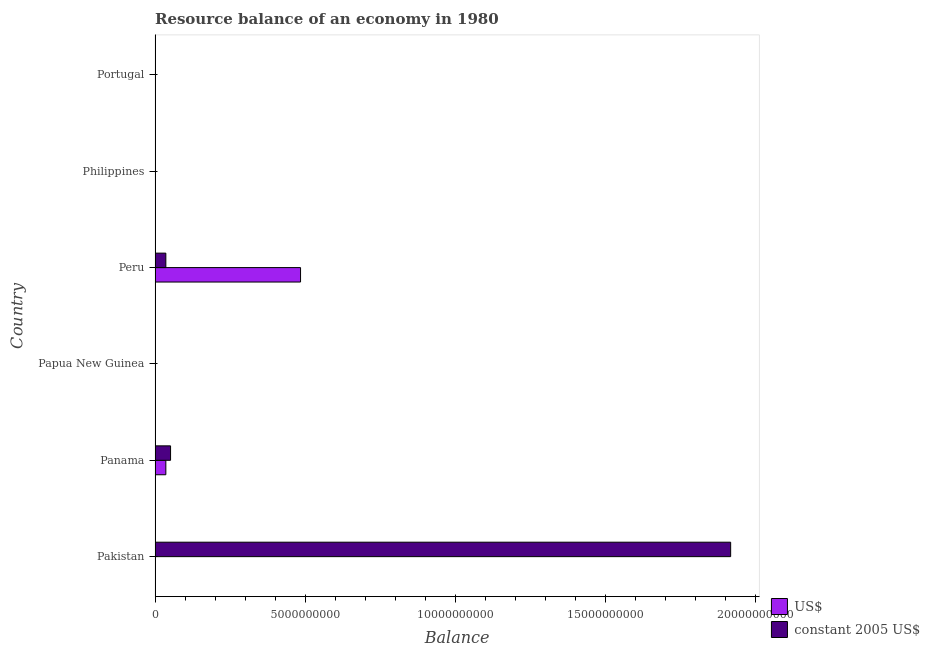How many different coloured bars are there?
Offer a terse response. 2. How many bars are there on the 5th tick from the top?
Your answer should be compact. 2. How many bars are there on the 3rd tick from the bottom?
Offer a terse response. 0. In how many cases, is the number of bars for a given country not equal to the number of legend labels?
Keep it short and to the point. 4. Across all countries, what is the maximum resource balance in constant us$?
Offer a very short reply. 1.92e+1. Across all countries, what is the minimum resource balance in constant us$?
Keep it short and to the point. 0. What is the total resource balance in us$ in the graph?
Give a very brief answer. 5.21e+09. What is the difference between the resource balance in constant us$ in Peru and that in Portugal?
Ensure brevity in your answer.  3.59e+08. What is the average resource balance in constant us$ per country?
Make the answer very short. 3.34e+09. What is the difference between the resource balance in constant us$ and resource balance in us$ in Peru?
Provide a short and direct response. -4.49e+09. What is the ratio of the resource balance in constant us$ in Panama to that in Peru?
Provide a succinct answer. 1.44. What is the difference between the highest and the second highest resource balance in constant us$?
Your answer should be very brief. 1.87e+1. What is the difference between the highest and the lowest resource balance in us$?
Offer a very short reply. 4.85e+09. In how many countries, is the resource balance in constant us$ greater than the average resource balance in constant us$ taken over all countries?
Ensure brevity in your answer.  1. Are the values on the major ticks of X-axis written in scientific E-notation?
Provide a short and direct response. No. Does the graph contain grids?
Your response must be concise. No. Where does the legend appear in the graph?
Your response must be concise. Bottom right. How many legend labels are there?
Provide a short and direct response. 2. What is the title of the graph?
Provide a succinct answer. Resource balance of an economy in 1980. Does "Young" appear as one of the legend labels in the graph?
Your response must be concise. No. What is the label or title of the X-axis?
Provide a short and direct response. Balance. What is the Balance of US$ in Pakistan?
Your answer should be very brief. 0. What is the Balance in constant 2005 US$ in Pakistan?
Ensure brevity in your answer.  1.92e+1. What is the Balance of US$ in Panama?
Ensure brevity in your answer.  3.59e+08. What is the Balance in constant 2005 US$ in Panama?
Your answer should be very brief. 5.17e+08. What is the Balance of US$ in Peru?
Your answer should be compact. 4.85e+09. What is the Balance in constant 2005 US$ in Peru?
Your answer should be very brief. 3.59e+08. What is the Balance in constant 2005 US$ in Philippines?
Ensure brevity in your answer.  0. What is the Balance in constant 2005 US$ in Portugal?
Ensure brevity in your answer.  1400. Across all countries, what is the maximum Balance of US$?
Give a very brief answer. 4.85e+09. Across all countries, what is the maximum Balance of constant 2005 US$?
Offer a very short reply. 1.92e+1. Across all countries, what is the minimum Balance in constant 2005 US$?
Keep it short and to the point. 0. What is the total Balance in US$ in the graph?
Give a very brief answer. 5.21e+09. What is the total Balance in constant 2005 US$ in the graph?
Offer a very short reply. 2.01e+1. What is the difference between the Balance of constant 2005 US$ in Pakistan and that in Panama?
Your response must be concise. 1.87e+1. What is the difference between the Balance in constant 2005 US$ in Pakistan and that in Peru?
Offer a terse response. 1.88e+1. What is the difference between the Balance in constant 2005 US$ in Pakistan and that in Portugal?
Your response must be concise. 1.92e+1. What is the difference between the Balance of US$ in Panama and that in Peru?
Provide a succinct answer. -4.49e+09. What is the difference between the Balance of constant 2005 US$ in Panama and that in Peru?
Give a very brief answer. 1.57e+08. What is the difference between the Balance of constant 2005 US$ in Panama and that in Portugal?
Your response must be concise. 5.17e+08. What is the difference between the Balance in constant 2005 US$ in Peru and that in Portugal?
Your answer should be very brief. 3.59e+08. What is the difference between the Balance in US$ in Panama and the Balance in constant 2005 US$ in Portugal?
Provide a succinct answer. 3.59e+08. What is the difference between the Balance in US$ in Peru and the Balance in constant 2005 US$ in Portugal?
Offer a very short reply. 4.85e+09. What is the average Balance in US$ per country?
Offer a terse response. 8.68e+08. What is the average Balance in constant 2005 US$ per country?
Provide a succinct answer. 3.34e+09. What is the difference between the Balance of US$ and Balance of constant 2005 US$ in Panama?
Your answer should be very brief. -1.57e+08. What is the difference between the Balance in US$ and Balance in constant 2005 US$ in Peru?
Offer a very short reply. 4.49e+09. What is the ratio of the Balance of constant 2005 US$ in Pakistan to that in Panama?
Ensure brevity in your answer.  37.12. What is the ratio of the Balance in constant 2005 US$ in Pakistan to that in Peru?
Keep it short and to the point. 53.35. What is the ratio of the Balance in constant 2005 US$ in Pakistan to that in Portugal?
Provide a succinct answer. 1.37e+07. What is the ratio of the Balance in US$ in Panama to that in Peru?
Your answer should be compact. 0.07. What is the ratio of the Balance in constant 2005 US$ in Panama to that in Peru?
Keep it short and to the point. 1.44. What is the ratio of the Balance of constant 2005 US$ in Panama to that in Portugal?
Offer a very short reply. 3.69e+05. What is the ratio of the Balance of constant 2005 US$ in Peru to that in Portugal?
Keep it short and to the point. 2.57e+05. What is the difference between the highest and the second highest Balance in constant 2005 US$?
Your response must be concise. 1.87e+1. What is the difference between the highest and the lowest Balance in US$?
Give a very brief answer. 4.85e+09. What is the difference between the highest and the lowest Balance in constant 2005 US$?
Your answer should be very brief. 1.92e+1. 